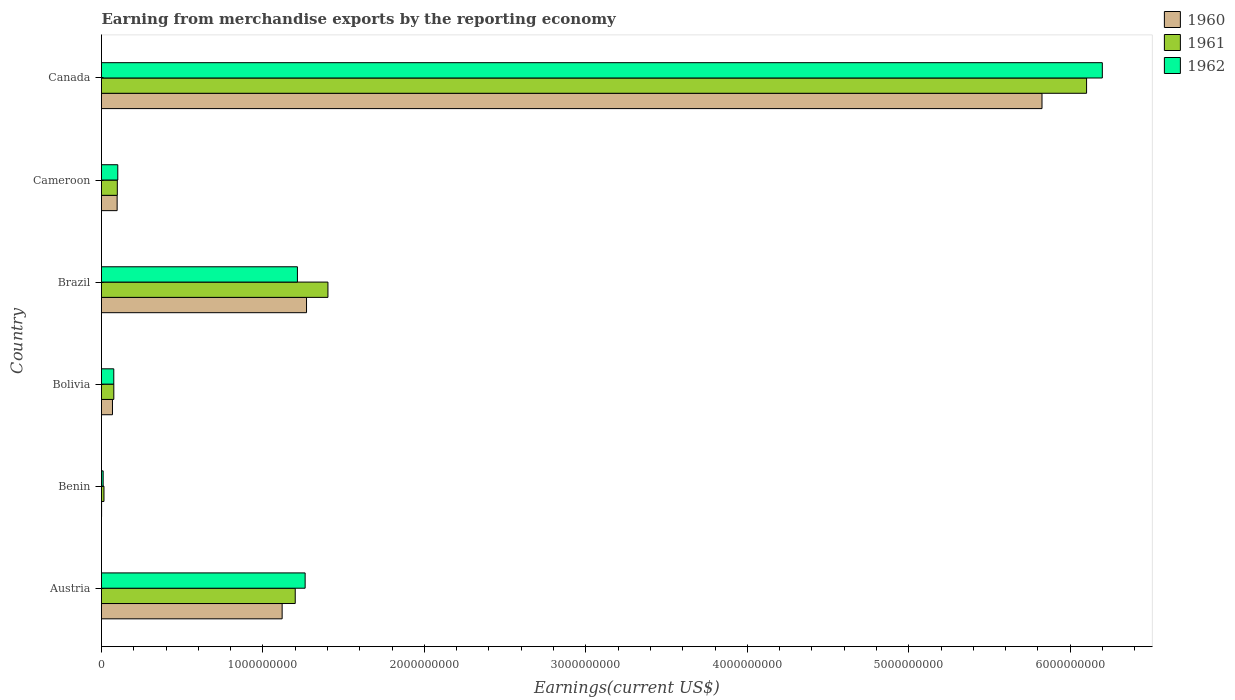Are the number of bars on each tick of the Y-axis equal?
Ensure brevity in your answer.  Yes. How many bars are there on the 2nd tick from the top?
Your response must be concise. 3. What is the label of the 5th group of bars from the top?
Give a very brief answer. Benin. What is the amount earned from merchandise exports in 1962 in Canada?
Offer a terse response. 6.20e+09. Across all countries, what is the maximum amount earned from merchandise exports in 1961?
Your answer should be compact. 6.10e+09. Across all countries, what is the minimum amount earned from merchandise exports in 1960?
Your answer should be very brief. 5.00e+05. In which country was the amount earned from merchandise exports in 1962 maximum?
Offer a very short reply. Canada. In which country was the amount earned from merchandise exports in 1962 minimum?
Offer a terse response. Benin. What is the total amount earned from merchandise exports in 1960 in the graph?
Your answer should be compact. 8.38e+09. What is the difference between the amount earned from merchandise exports in 1961 in Austria and that in Cameroon?
Offer a very short reply. 1.10e+09. What is the difference between the amount earned from merchandise exports in 1961 in Canada and the amount earned from merchandise exports in 1962 in Austria?
Give a very brief answer. 4.84e+09. What is the average amount earned from merchandise exports in 1960 per country?
Offer a terse response. 1.40e+09. What is the difference between the amount earned from merchandise exports in 1962 and amount earned from merchandise exports in 1960 in Austria?
Your answer should be very brief. 1.42e+08. What is the ratio of the amount earned from merchandise exports in 1962 in Benin to that in Bolivia?
Keep it short and to the point. 0.13. What is the difference between the highest and the second highest amount earned from merchandise exports in 1960?
Give a very brief answer. 4.56e+09. What is the difference between the highest and the lowest amount earned from merchandise exports in 1960?
Offer a terse response. 5.82e+09. What does the 1st bar from the bottom in Cameroon represents?
Your answer should be compact. 1960. Is it the case that in every country, the sum of the amount earned from merchandise exports in 1962 and amount earned from merchandise exports in 1961 is greater than the amount earned from merchandise exports in 1960?
Keep it short and to the point. Yes. How many bars are there?
Keep it short and to the point. 18. Are all the bars in the graph horizontal?
Offer a very short reply. Yes. Are the values on the major ticks of X-axis written in scientific E-notation?
Your answer should be very brief. No. Does the graph contain grids?
Ensure brevity in your answer.  No. What is the title of the graph?
Offer a very short reply. Earning from merchandise exports by the reporting economy. Does "1968" appear as one of the legend labels in the graph?
Ensure brevity in your answer.  No. What is the label or title of the X-axis?
Provide a succinct answer. Earnings(current US$). What is the label or title of the Y-axis?
Offer a terse response. Country. What is the Earnings(current US$) in 1960 in Austria?
Provide a short and direct response. 1.12e+09. What is the Earnings(current US$) in 1961 in Austria?
Your answer should be very brief. 1.20e+09. What is the Earnings(current US$) of 1962 in Austria?
Make the answer very short. 1.26e+09. What is the Earnings(current US$) of 1960 in Benin?
Your answer should be very brief. 5.00e+05. What is the Earnings(current US$) in 1961 in Benin?
Provide a short and direct response. 1.53e+07. What is the Earnings(current US$) of 1962 in Benin?
Make the answer very short. 1.02e+07. What is the Earnings(current US$) in 1960 in Bolivia?
Provide a short and direct response. 6.79e+07. What is the Earnings(current US$) in 1961 in Bolivia?
Your answer should be compact. 7.62e+07. What is the Earnings(current US$) in 1962 in Bolivia?
Offer a very short reply. 7.60e+07. What is the Earnings(current US$) of 1960 in Brazil?
Keep it short and to the point. 1.27e+09. What is the Earnings(current US$) of 1961 in Brazil?
Give a very brief answer. 1.40e+09. What is the Earnings(current US$) in 1962 in Brazil?
Ensure brevity in your answer.  1.21e+09. What is the Earnings(current US$) of 1960 in Cameroon?
Your response must be concise. 9.69e+07. What is the Earnings(current US$) in 1961 in Cameroon?
Provide a short and direct response. 9.79e+07. What is the Earnings(current US$) in 1962 in Cameroon?
Your answer should be very brief. 1.01e+08. What is the Earnings(current US$) of 1960 in Canada?
Ensure brevity in your answer.  5.83e+09. What is the Earnings(current US$) in 1961 in Canada?
Provide a succinct answer. 6.10e+09. What is the Earnings(current US$) of 1962 in Canada?
Your answer should be very brief. 6.20e+09. Across all countries, what is the maximum Earnings(current US$) of 1960?
Your answer should be very brief. 5.83e+09. Across all countries, what is the maximum Earnings(current US$) in 1961?
Ensure brevity in your answer.  6.10e+09. Across all countries, what is the maximum Earnings(current US$) in 1962?
Keep it short and to the point. 6.20e+09. Across all countries, what is the minimum Earnings(current US$) of 1961?
Ensure brevity in your answer.  1.53e+07. Across all countries, what is the minimum Earnings(current US$) in 1962?
Keep it short and to the point. 1.02e+07. What is the total Earnings(current US$) of 1960 in the graph?
Keep it short and to the point. 8.38e+09. What is the total Earnings(current US$) of 1961 in the graph?
Offer a terse response. 8.89e+09. What is the total Earnings(current US$) of 1962 in the graph?
Provide a succinct answer. 8.86e+09. What is the difference between the Earnings(current US$) in 1960 in Austria and that in Benin?
Your response must be concise. 1.12e+09. What is the difference between the Earnings(current US$) in 1961 in Austria and that in Benin?
Keep it short and to the point. 1.18e+09. What is the difference between the Earnings(current US$) in 1962 in Austria and that in Benin?
Offer a very short reply. 1.25e+09. What is the difference between the Earnings(current US$) of 1960 in Austria and that in Bolivia?
Your response must be concise. 1.05e+09. What is the difference between the Earnings(current US$) in 1961 in Austria and that in Bolivia?
Your response must be concise. 1.12e+09. What is the difference between the Earnings(current US$) of 1962 in Austria and that in Bolivia?
Keep it short and to the point. 1.19e+09. What is the difference between the Earnings(current US$) of 1960 in Austria and that in Brazil?
Provide a short and direct response. -1.51e+08. What is the difference between the Earnings(current US$) of 1961 in Austria and that in Brazil?
Ensure brevity in your answer.  -2.02e+08. What is the difference between the Earnings(current US$) in 1962 in Austria and that in Brazil?
Offer a terse response. 4.78e+07. What is the difference between the Earnings(current US$) of 1960 in Austria and that in Cameroon?
Offer a terse response. 1.02e+09. What is the difference between the Earnings(current US$) of 1961 in Austria and that in Cameroon?
Ensure brevity in your answer.  1.10e+09. What is the difference between the Earnings(current US$) of 1962 in Austria and that in Cameroon?
Provide a short and direct response. 1.16e+09. What is the difference between the Earnings(current US$) in 1960 in Austria and that in Canada?
Your answer should be very brief. -4.71e+09. What is the difference between the Earnings(current US$) in 1961 in Austria and that in Canada?
Provide a succinct answer. -4.90e+09. What is the difference between the Earnings(current US$) of 1962 in Austria and that in Canada?
Make the answer very short. -4.94e+09. What is the difference between the Earnings(current US$) of 1960 in Benin and that in Bolivia?
Offer a terse response. -6.74e+07. What is the difference between the Earnings(current US$) of 1961 in Benin and that in Bolivia?
Provide a succinct answer. -6.09e+07. What is the difference between the Earnings(current US$) in 1962 in Benin and that in Bolivia?
Provide a succinct answer. -6.58e+07. What is the difference between the Earnings(current US$) of 1960 in Benin and that in Brazil?
Give a very brief answer. -1.27e+09. What is the difference between the Earnings(current US$) in 1961 in Benin and that in Brazil?
Your answer should be very brief. -1.39e+09. What is the difference between the Earnings(current US$) in 1962 in Benin and that in Brazil?
Offer a very short reply. -1.20e+09. What is the difference between the Earnings(current US$) of 1960 in Benin and that in Cameroon?
Make the answer very short. -9.64e+07. What is the difference between the Earnings(current US$) of 1961 in Benin and that in Cameroon?
Give a very brief answer. -8.26e+07. What is the difference between the Earnings(current US$) of 1962 in Benin and that in Cameroon?
Make the answer very short. -9.06e+07. What is the difference between the Earnings(current US$) of 1960 in Benin and that in Canada?
Provide a succinct answer. -5.82e+09. What is the difference between the Earnings(current US$) of 1961 in Benin and that in Canada?
Your answer should be compact. -6.09e+09. What is the difference between the Earnings(current US$) in 1962 in Benin and that in Canada?
Make the answer very short. -6.19e+09. What is the difference between the Earnings(current US$) of 1960 in Bolivia and that in Brazil?
Make the answer very short. -1.20e+09. What is the difference between the Earnings(current US$) of 1961 in Bolivia and that in Brazil?
Your response must be concise. -1.33e+09. What is the difference between the Earnings(current US$) of 1962 in Bolivia and that in Brazil?
Offer a very short reply. -1.14e+09. What is the difference between the Earnings(current US$) in 1960 in Bolivia and that in Cameroon?
Provide a short and direct response. -2.90e+07. What is the difference between the Earnings(current US$) of 1961 in Bolivia and that in Cameroon?
Ensure brevity in your answer.  -2.17e+07. What is the difference between the Earnings(current US$) in 1962 in Bolivia and that in Cameroon?
Your response must be concise. -2.48e+07. What is the difference between the Earnings(current US$) of 1960 in Bolivia and that in Canada?
Give a very brief answer. -5.76e+09. What is the difference between the Earnings(current US$) of 1961 in Bolivia and that in Canada?
Offer a terse response. -6.03e+09. What is the difference between the Earnings(current US$) in 1962 in Bolivia and that in Canada?
Offer a terse response. -6.12e+09. What is the difference between the Earnings(current US$) of 1960 in Brazil and that in Cameroon?
Give a very brief answer. 1.17e+09. What is the difference between the Earnings(current US$) in 1961 in Brazil and that in Cameroon?
Make the answer very short. 1.30e+09. What is the difference between the Earnings(current US$) in 1962 in Brazil and that in Cameroon?
Your answer should be compact. 1.11e+09. What is the difference between the Earnings(current US$) in 1960 in Brazil and that in Canada?
Give a very brief answer. -4.56e+09. What is the difference between the Earnings(current US$) in 1961 in Brazil and that in Canada?
Ensure brevity in your answer.  -4.70e+09. What is the difference between the Earnings(current US$) of 1962 in Brazil and that in Canada?
Give a very brief answer. -4.99e+09. What is the difference between the Earnings(current US$) of 1960 in Cameroon and that in Canada?
Make the answer very short. -5.73e+09. What is the difference between the Earnings(current US$) of 1961 in Cameroon and that in Canada?
Your answer should be compact. -6.00e+09. What is the difference between the Earnings(current US$) in 1962 in Cameroon and that in Canada?
Offer a terse response. -6.10e+09. What is the difference between the Earnings(current US$) in 1960 in Austria and the Earnings(current US$) in 1961 in Benin?
Keep it short and to the point. 1.10e+09. What is the difference between the Earnings(current US$) of 1960 in Austria and the Earnings(current US$) of 1962 in Benin?
Make the answer very short. 1.11e+09. What is the difference between the Earnings(current US$) in 1961 in Austria and the Earnings(current US$) in 1962 in Benin?
Ensure brevity in your answer.  1.19e+09. What is the difference between the Earnings(current US$) in 1960 in Austria and the Earnings(current US$) in 1961 in Bolivia?
Your answer should be compact. 1.04e+09. What is the difference between the Earnings(current US$) of 1960 in Austria and the Earnings(current US$) of 1962 in Bolivia?
Make the answer very short. 1.04e+09. What is the difference between the Earnings(current US$) in 1961 in Austria and the Earnings(current US$) in 1962 in Bolivia?
Your answer should be very brief. 1.12e+09. What is the difference between the Earnings(current US$) of 1960 in Austria and the Earnings(current US$) of 1961 in Brazil?
Ensure brevity in your answer.  -2.84e+08. What is the difference between the Earnings(current US$) in 1960 in Austria and the Earnings(current US$) in 1962 in Brazil?
Provide a short and direct response. -9.46e+07. What is the difference between the Earnings(current US$) in 1961 in Austria and the Earnings(current US$) in 1962 in Brazil?
Offer a terse response. -1.35e+07. What is the difference between the Earnings(current US$) in 1960 in Austria and the Earnings(current US$) in 1961 in Cameroon?
Ensure brevity in your answer.  1.02e+09. What is the difference between the Earnings(current US$) in 1960 in Austria and the Earnings(current US$) in 1962 in Cameroon?
Ensure brevity in your answer.  1.02e+09. What is the difference between the Earnings(current US$) of 1961 in Austria and the Earnings(current US$) of 1962 in Cameroon?
Give a very brief answer. 1.10e+09. What is the difference between the Earnings(current US$) in 1960 in Austria and the Earnings(current US$) in 1961 in Canada?
Give a very brief answer. -4.98e+09. What is the difference between the Earnings(current US$) of 1960 in Austria and the Earnings(current US$) of 1962 in Canada?
Ensure brevity in your answer.  -5.08e+09. What is the difference between the Earnings(current US$) of 1961 in Austria and the Earnings(current US$) of 1962 in Canada?
Your answer should be very brief. -5.00e+09. What is the difference between the Earnings(current US$) of 1960 in Benin and the Earnings(current US$) of 1961 in Bolivia?
Keep it short and to the point. -7.57e+07. What is the difference between the Earnings(current US$) of 1960 in Benin and the Earnings(current US$) of 1962 in Bolivia?
Make the answer very short. -7.55e+07. What is the difference between the Earnings(current US$) in 1961 in Benin and the Earnings(current US$) in 1962 in Bolivia?
Provide a short and direct response. -6.07e+07. What is the difference between the Earnings(current US$) in 1960 in Benin and the Earnings(current US$) in 1961 in Brazil?
Keep it short and to the point. -1.40e+09. What is the difference between the Earnings(current US$) in 1960 in Benin and the Earnings(current US$) in 1962 in Brazil?
Offer a terse response. -1.21e+09. What is the difference between the Earnings(current US$) in 1961 in Benin and the Earnings(current US$) in 1962 in Brazil?
Offer a terse response. -1.20e+09. What is the difference between the Earnings(current US$) in 1960 in Benin and the Earnings(current US$) in 1961 in Cameroon?
Keep it short and to the point. -9.74e+07. What is the difference between the Earnings(current US$) in 1960 in Benin and the Earnings(current US$) in 1962 in Cameroon?
Offer a terse response. -1.00e+08. What is the difference between the Earnings(current US$) in 1961 in Benin and the Earnings(current US$) in 1962 in Cameroon?
Offer a terse response. -8.55e+07. What is the difference between the Earnings(current US$) in 1960 in Benin and the Earnings(current US$) in 1961 in Canada?
Keep it short and to the point. -6.10e+09. What is the difference between the Earnings(current US$) of 1960 in Benin and the Earnings(current US$) of 1962 in Canada?
Provide a short and direct response. -6.20e+09. What is the difference between the Earnings(current US$) of 1961 in Benin and the Earnings(current US$) of 1962 in Canada?
Provide a short and direct response. -6.18e+09. What is the difference between the Earnings(current US$) in 1960 in Bolivia and the Earnings(current US$) in 1961 in Brazil?
Make the answer very short. -1.33e+09. What is the difference between the Earnings(current US$) in 1960 in Bolivia and the Earnings(current US$) in 1962 in Brazil?
Your answer should be very brief. -1.15e+09. What is the difference between the Earnings(current US$) in 1961 in Bolivia and the Earnings(current US$) in 1962 in Brazil?
Your response must be concise. -1.14e+09. What is the difference between the Earnings(current US$) of 1960 in Bolivia and the Earnings(current US$) of 1961 in Cameroon?
Make the answer very short. -3.00e+07. What is the difference between the Earnings(current US$) of 1960 in Bolivia and the Earnings(current US$) of 1962 in Cameroon?
Provide a succinct answer. -3.29e+07. What is the difference between the Earnings(current US$) in 1961 in Bolivia and the Earnings(current US$) in 1962 in Cameroon?
Your response must be concise. -2.46e+07. What is the difference between the Earnings(current US$) in 1960 in Bolivia and the Earnings(current US$) in 1961 in Canada?
Your response must be concise. -6.03e+09. What is the difference between the Earnings(current US$) of 1960 in Bolivia and the Earnings(current US$) of 1962 in Canada?
Your response must be concise. -6.13e+09. What is the difference between the Earnings(current US$) of 1961 in Bolivia and the Earnings(current US$) of 1962 in Canada?
Provide a short and direct response. -6.12e+09. What is the difference between the Earnings(current US$) of 1960 in Brazil and the Earnings(current US$) of 1961 in Cameroon?
Give a very brief answer. 1.17e+09. What is the difference between the Earnings(current US$) in 1960 in Brazil and the Earnings(current US$) in 1962 in Cameroon?
Ensure brevity in your answer.  1.17e+09. What is the difference between the Earnings(current US$) in 1961 in Brazil and the Earnings(current US$) in 1962 in Cameroon?
Your answer should be compact. 1.30e+09. What is the difference between the Earnings(current US$) in 1960 in Brazil and the Earnings(current US$) in 1961 in Canada?
Your answer should be compact. -4.83e+09. What is the difference between the Earnings(current US$) of 1960 in Brazil and the Earnings(current US$) of 1962 in Canada?
Make the answer very short. -4.93e+09. What is the difference between the Earnings(current US$) of 1961 in Brazil and the Earnings(current US$) of 1962 in Canada?
Keep it short and to the point. -4.80e+09. What is the difference between the Earnings(current US$) in 1960 in Cameroon and the Earnings(current US$) in 1961 in Canada?
Your answer should be very brief. -6.00e+09. What is the difference between the Earnings(current US$) of 1960 in Cameroon and the Earnings(current US$) of 1962 in Canada?
Make the answer very short. -6.10e+09. What is the difference between the Earnings(current US$) of 1961 in Cameroon and the Earnings(current US$) of 1962 in Canada?
Your response must be concise. -6.10e+09. What is the average Earnings(current US$) in 1960 per country?
Offer a terse response. 1.40e+09. What is the average Earnings(current US$) of 1961 per country?
Keep it short and to the point. 1.48e+09. What is the average Earnings(current US$) in 1962 per country?
Provide a succinct answer. 1.48e+09. What is the difference between the Earnings(current US$) in 1960 and Earnings(current US$) in 1961 in Austria?
Provide a short and direct response. -8.11e+07. What is the difference between the Earnings(current US$) of 1960 and Earnings(current US$) of 1962 in Austria?
Your response must be concise. -1.42e+08. What is the difference between the Earnings(current US$) of 1961 and Earnings(current US$) of 1962 in Austria?
Keep it short and to the point. -6.13e+07. What is the difference between the Earnings(current US$) of 1960 and Earnings(current US$) of 1961 in Benin?
Your answer should be very brief. -1.48e+07. What is the difference between the Earnings(current US$) in 1960 and Earnings(current US$) in 1962 in Benin?
Make the answer very short. -9.70e+06. What is the difference between the Earnings(current US$) of 1961 and Earnings(current US$) of 1962 in Benin?
Offer a very short reply. 5.10e+06. What is the difference between the Earnings(current US$) of 1960 and Earnings(current US$) of 1961 in Bolivia?
Keep it short and to the point. -8.30e+06. What is the difference between the Earnings(current US$) in 1960 and Earnings(current US$) in 1962 in Bolivia?
Your answer should be very brief. -8.10e+06. What is the difference between the Earnings(current US$) in 1961 and Earnings(current US$) in 1962 in Bolivia?
Give a very brief answer. 2.00e+05. What is the difference between the Earnings(current US$) in 1960 and Earnings(current US$) in 1961 in Brazil?
Ensure brevity in your answer.  -1.33e+08. What is the difference between the Earnings(current US$) of 1960 and Earnings(current US$) of 1962 in Brazil?
Give a very brief answer. 5.64e+07. What is the difference between the Earnings(current US$) of 1961 and Earnings(current US$) of 1962 in Brazil?
Offer a very short reply. 1.89e+08. What is the difference between the Earnings(current US$) in 1960 and Earnings(current US$) in 1961 in Cameroon?
Provide a short and direct response. -1.00e+06. What is the difference between the Earnings(current US$) in 1960 and Earnings(current US$) in 1962 in Cameroon?
Offer a very short reply. -3.90e+06. What is the difference between the Earnings(current US$) of 1961 and Earnings(current US$) of 1962 in Cameroon?
Offer a very short reply. -2.90e+06. What is the difference between the Earnings(current US$) of 1960 and Earnings(current US$) of 1961 in Canada?
Provide a succinct answer. -2.76e+08. What is the difference between the Earnings(current US$) in 1960 and Earnings(current US$) in 1962 in Canada?
Keep it short and to the point. -3.74e+08. What is the difference between the Earnings(current US$) in 1961 and Earnings(current US$) in 1962 in Canada?
Your response must be concise. -9.75e+07. What is the ratio of the Earnings(current US$) of 1960 in Austria to that in Benin?
Provide a short and direct response. 2237.8. What is the ratio of the Earnings(current US$) in 1961 in Austria to that in Benin?
Keep it short and to the point. 78.43. What is the ratio of the Earnings(current US$) in 1962 in Austria to that in Benin?
Your answer should be very brief. 123.66. What is the ratio of the Earnings(current US$) in 1960 in Austria to that in Bolivia?
Your answer should be compact. 16.48. What is the ratio of the Earnings(current US$) of 1961 in Austria to that in Bolivia?
Offer a very short reply. 15.75. What is the ratio of the Earnings(current US$) in 1962 in Austria to that in Bolivia?
Provide a short and direct response. 16.6. What is the ratio of the Earnings(current US$) of 1960 in Austria to that in Brazil?
Give a very brief answer. 0.88. What is the ratio of the Earnings(current US$) of 1961 in Austria to that in Brazil?
Provide a short and direct response. 0.86. What is the ratio of the Earnings(current US$) of 1962 in Austria to that in Brazil?
Provide a succinct answer. 1.04. What is the ratio of the Earnings(current US$) of 1960 in Austria to that in Cameroon?
Your answer should be compact. 11.55. What is the ratio of the Earnings(current US$) of 1961 in Austria to that in Cameroon?
Make the answer very short. 12.26. What is the ratio of the Earnings(current US$) of 1962 in Austria to that in Cameroon?
Make the answer very short. 12.51. What is the ratio of the Earnings(current US$) in 1960 in Austria to that in Canada?
Offer a terse response. 0.19. What is the ratio of the Earnings(current US$) of 1961 in Austria to that in Canada?
Provide a succinct answer. 0.2. What is the ratio of the Earnings(current US$) in 1962 in Austria to that in Canada?
Your answer should be compact. 0.2. What is the ratio of the Earnings(current US$) of 1960 in Benin to that in Bolivia?
Your answer should be compact. 0.01. What is the ratio of the Earnings(current US$) in 1961 in Benin to that in Bolivia?
Provide a succinct answer. 0.2. What is the ratio of the Earnings(current US$) in 1962 in Benin to that in Bolivia?
Keep it short and to the point. 0.13. What is the ratio of the Earnings(current US$) in 1961 in Benin to that in Brazil?
Your response must be concise. 0.01. What is the ratio of the Earnings(current US$) in 1962 in Benin to that in Brazil?
Provide a short and direct response. 0.01. What is the ratio of the Earnings(current US$) of 1960 in Benin to that in Cameroon?
Offer a terse response. 0.01. What is the ratio of the Earnings(current US$) in 1961 in Benin to that in Cameroon?
Ensure brevity in your answer.  0.16. What is the ratio of the Earnings(current US$) of 1962 in Benin to that in Cameroon?
Provide a succinct answer. 0.1. What is the ratio of the Earnings(current US$) of 1961 in Benin to that in Canada?
Your answer should be very brief. 0. What is the ratio of the Earnings(current US$) of 1962 in Benin to that in Canada?
Give a very brief answer. 0. What is the ratio of the Earnings(current US$) in 1960 in Bolivia to that in Brazil?
Provide a short and direct response. 0.05. What is the ratio of the Earnings(current US$) in 1961 in Bolivia to that in Brazil?
Offer a very short reply. 0.05. What is the ratio of the Earnings(current US$) in 1962 in Bolivia to that in Brazil?
Offer a terse response. 0.06. What is the ratio of the Earnings(current US$) in 1960 in Bolivia to that in Cameroon?
Make the answer very short. 0.7. What is the ratio of the Earnings(current US$) in 1961 in Bolivia to that in Cameroon?
Offer a very short reply. 0.78. What is the ratio of the Earnings(current US$) in 1962 in Bolivia to that in Cameroon?
Make the answer very short. 0.75. What is the ratio of the Earnings(current US$) of 1960 in Bolivia to that in Canada?
Make the answer very short. 0.01. What is the ratio of the Earnings(current US$) in 1961 in Bolivia to that in Canada?
Your answer should be compact. 0.01. What is the ratio of the Earnings(current US$) of 1962 in Bolivia to that in Canada?
Your answer should be compact. 0.01. What is the ratio of the Earnings(current US$) of 1960 in Brazil to that in Cameroon?
Your answer should be compact. 13.11. What is the ratio of the Earnings(current US$) of 1961 in Brazil to that in Cameroon?
Keep it short and to the point. 14.33. What is the ratio of the Earnings(current US$) of 1962 in Brazil to that in Cameroon?
Give a very brief answer. 12.04. What is the ratio of the Earnings(current US$) of 1960 in Brazil to that in Canada?
Offer a very short reply. 0.22. What is the ratio of the Earnings(current US$) in 1961 in Brazil to that in Canada?
Offer a terse response. 0.23. What is the ratio of the Earnings(current US$) in 1962 in Brazil to that in Canada?
Give a very brief answer. 0.2. What is the ratio of the Earnings(current US$) in 1960 in Cameroon to that in Canada?
Give a very brief answer. 0.02. What is the ratio of the Earnings(current US$) of 1961 in Cameroon to that in Canada?
Keep it short and to the point. 0.02. What is the ratio of the Earnings(current US$) of 1962 in Cameroon to that in Canada?
Provide a succinct answer. 0.02. What is the difference between the highest and the second highest Earnings(current US$) of 1960?
Offer a very short reply. 4.56e+09. What is the difference between the highest and the second highest Earnings(current US$) of 1961?
Make the answer very short. 4.70e+09. What is the difference between the highest and the second highest Earnings(current US$) in 1962?
Ensure brevity in your answer.  4.94e+09. What is the difference between the highest and the lowest Earnings(current US$) in 1960?
Offer a very short reply. 5.82e+09. What is the difference between the highest and the lowest Earnings(current US$) in 1961?
Your answer should be compact. 6.09e+09. What is the difference between the highest and the lowest Earnings(current US$) in 1962?
Provide a short and direct response. 6.19e+09. 